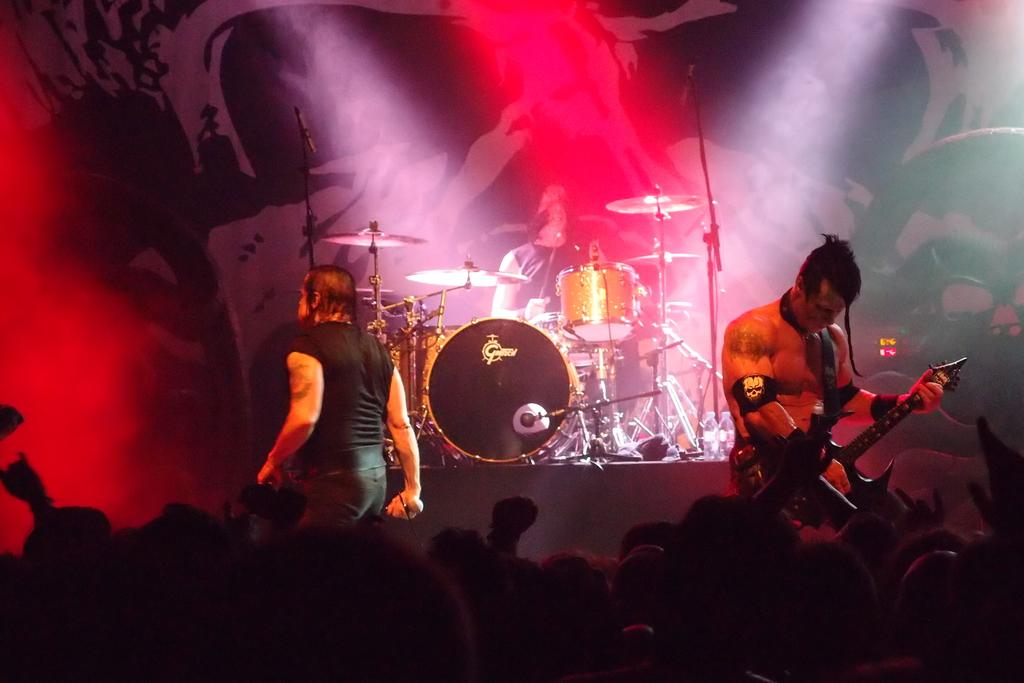What are the people in the image doing? There are people standing in the image, and some of them are playing musical instruments. Are there any other activities taking place in the image? Yes, there are people sitting in the image, and they are looking towards magicians. What type of snake can be seen slithering around the feet of the musicians in the image? There is no snake present in the image; the focus is on the people standing and playing musical instruments, as well as the sitting people looking towards magicians. 